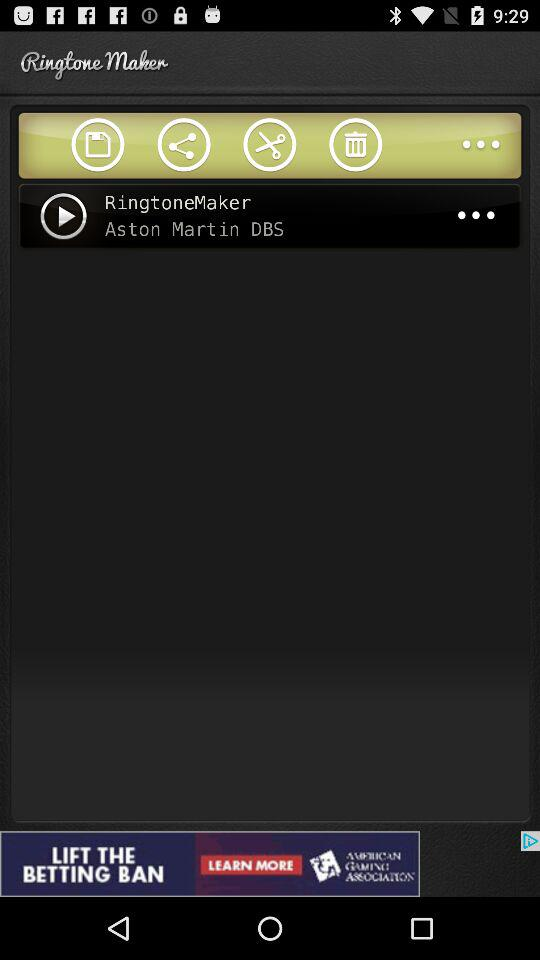What is the name of the application? The name of the application is "Ringtone Maker". 